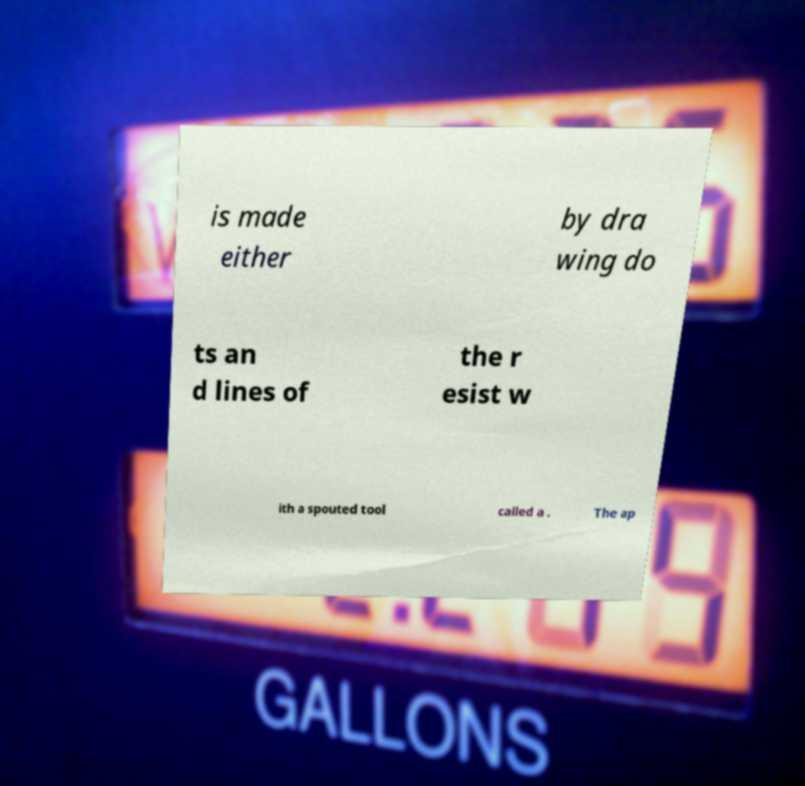Please identify and transcribe the text found in this image. is made either by dra wing do ts an d lines of the r esist w ith a spouted tool called a . The ap 